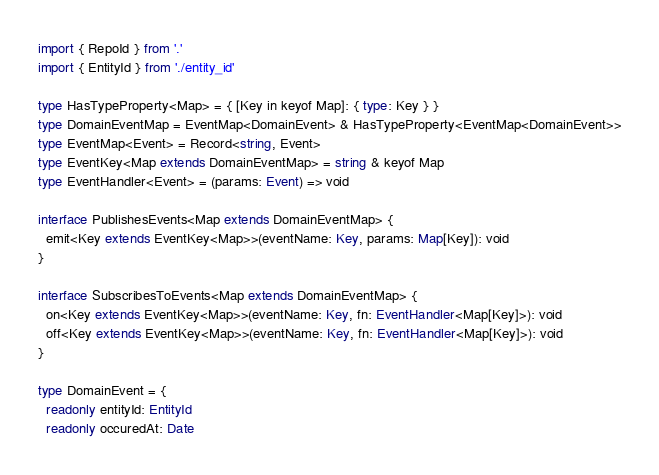<code> <loc_0><loc_0><loc_500><loc_500><_TypeScript_>import { RepoId } from '.'
import { EntityId } from './entity_id'

type HasTypeProperty<Map> = { [Key in keyof Map]: { type: Key } }
type DomainEventMap = EventMap<DomainEvent> & HasTypeProperty<EventMap<DomainEvent>>
type EventMap<Event> = Record<string, Event>
type EventKey<Map extends DomainEventMap> = string & keyof Map
type EventHandler<Event> = (params: Event) => void

interface PublishesEvents<Map extends DomainEventMap> {
  emit<Key extends EventKey<Map>>(eventName: Key, params: Map[Key]): void
}

interface SubscribesToEvents<Map extends DomainEventMap> {
  on<Key extends EventKey<Map>>(eventName: Key, fn: EventHandler<Map[Key]>): void
  off<Key extends EventKey<Map>>(eventName: Key, fn: EventHandler<Map[Key]>): void
}

type DomainEvent = {
  readonly entityId: EntityId
  readonly occuredAt: Date</code> 